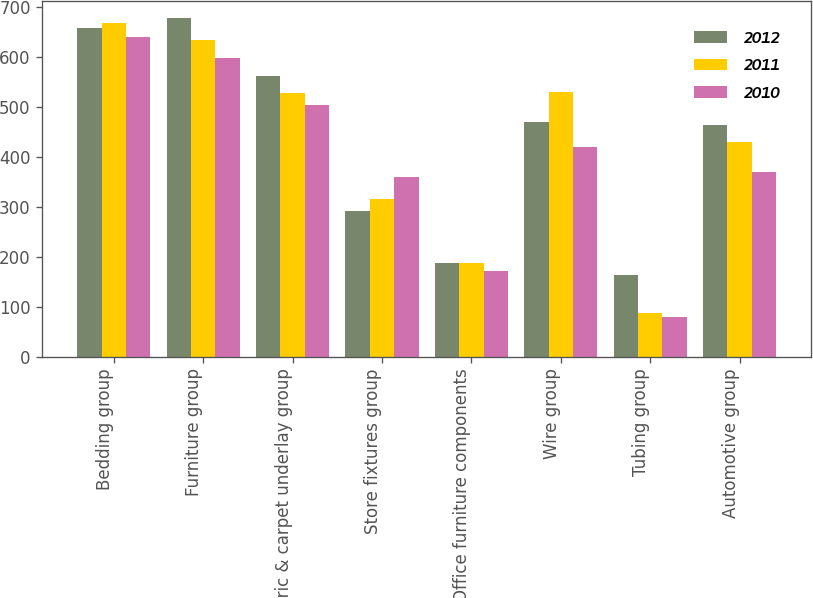<chart> <loc_0><loc_0><loc_500><loc_500><stacked_bar_chart><ecel><fcel>Bedding group<fcel>Furniture group<fcel>Fabric & carpet underlay group<fcel>Store fixtures group<fcel>Office furniture components<fcel>Wire group<fcel>Tubing group<fcel>Automotive group<nl><fcel>2012<fcel>657.6<fcel>676.9<fcel>560.5<fcel>291.6<fcel>186.7<fcel>469<fcel>163.9<fcel>463.5<nl><fcel>2011<fcel>667.2<fcel>633.6<fcel>527<fcel>315.7<fcel>186.7<fcel>529.8<fcel>86.9<fcel>428.7<nl><fcel>2010<fcel>638.6<fcel>596.8<fcel>503.9<fcel>360.2<fcel>170.5<fcel>418.4<fcel>79.6<fcel>368.9<nl></chart> 